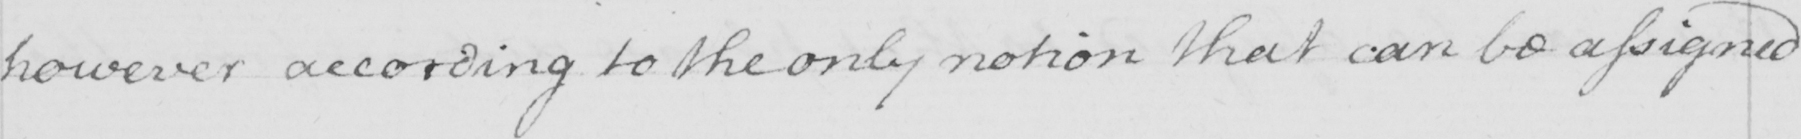Please provide the text content of this handwritten line. however according to the only notion that can be assigned 